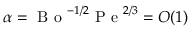<formula> <loc_0><loc_0><loc_500><loc_500>\alpha = B o ^ { - 1 / 2 } P e ^ { 2 / 3 } = O ( 1 )</formula> 